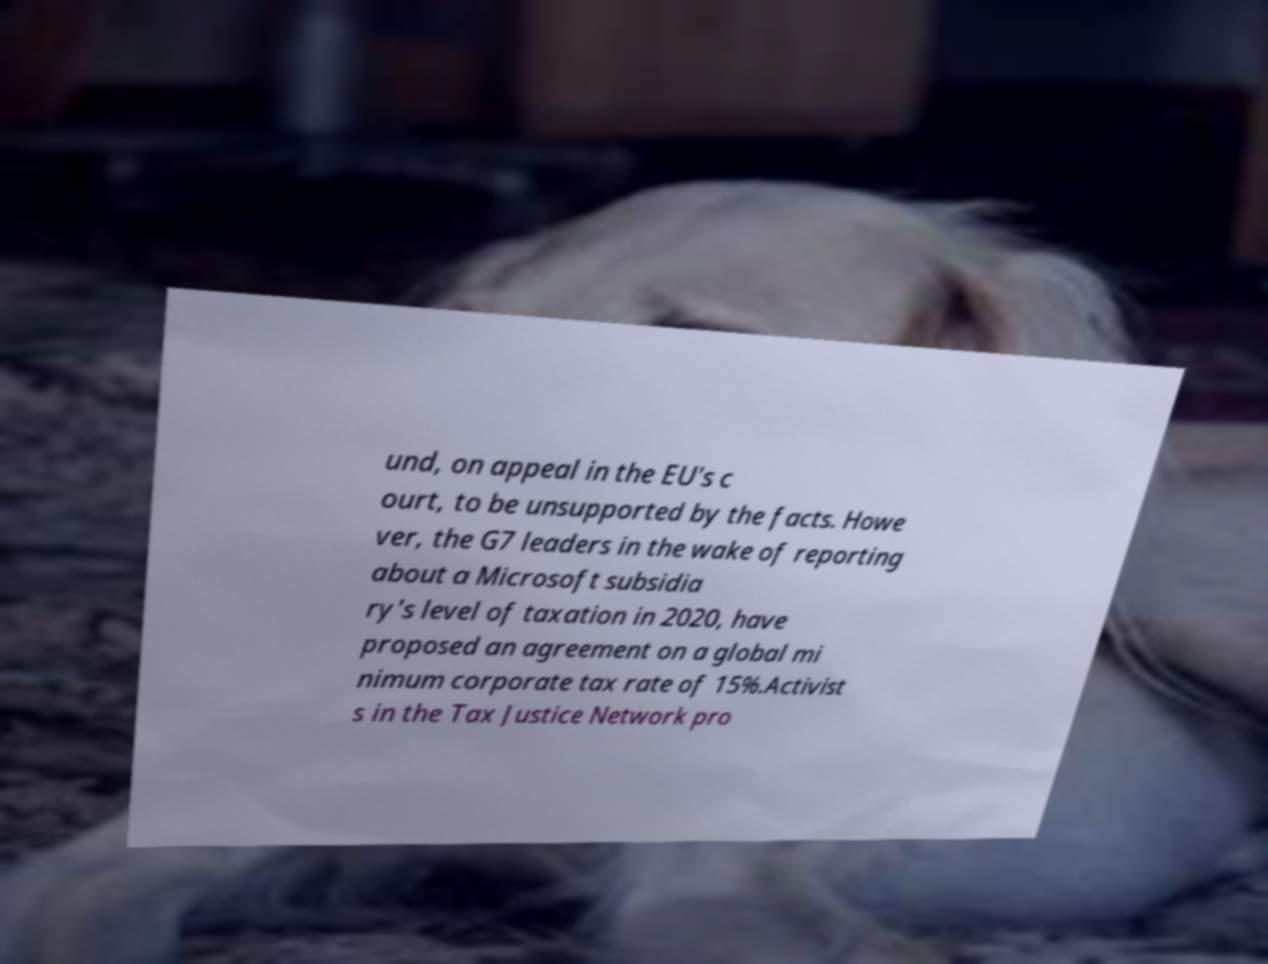There's text embedded in this image that I need extracted. Can you transcribe it verbatim? und, on appeal in the EU's c ourt, to be unsupported by the facts. Howe ver, the G7 leaders in the wake of reporting about a Microsoft subsidia ry's level of taxation in 2020, have proposed an agreement on a global mi nimum corporate tax rate of 15%.Activist s in the Tax Justice Network pro 